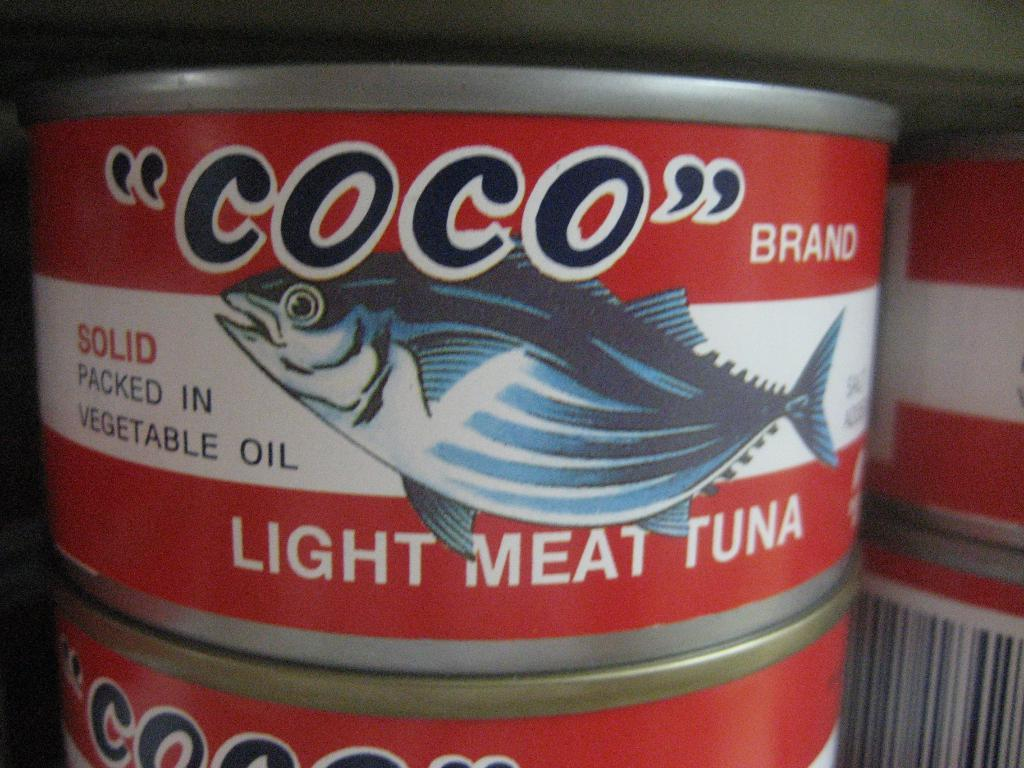<image>
Create a compact narrative representing the image presented. A can of COCO tuna has a blue fish on the label. 